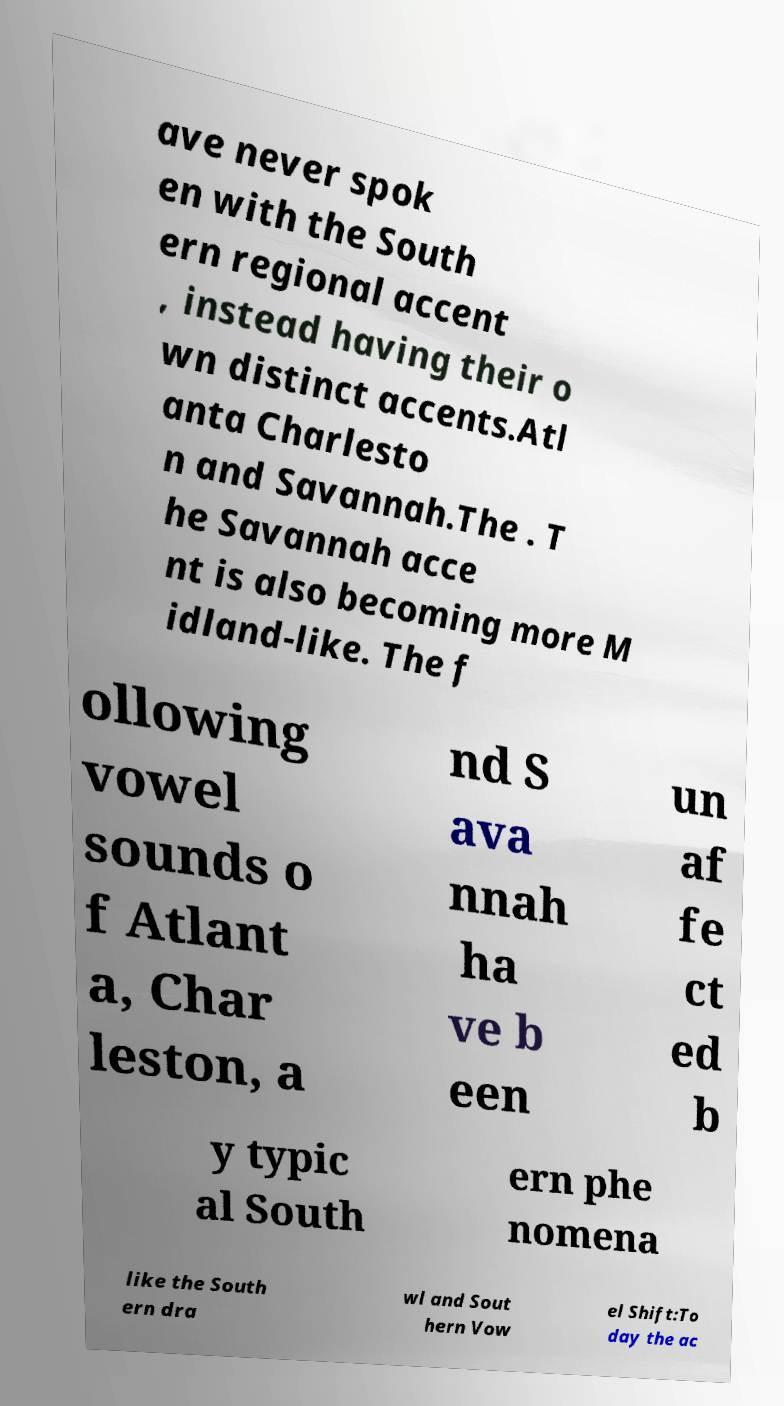Please read and relay the text visible in this image. What does it say? ave never spok en with the South ern regional accent , instead having their o wn distinct accents.Atl anta Charlesto n and Savannah.The . T he Savannah acce nt is also becoming more M idland-like. The f ollowing vowel sounds o f Atlant a, Char leston, a nd S ava nnah ha ve b een un af fe ct ed b y typic al South ern phe nomena like the South ern dra wl and Sout hern Vow el Shift:To day the ac 